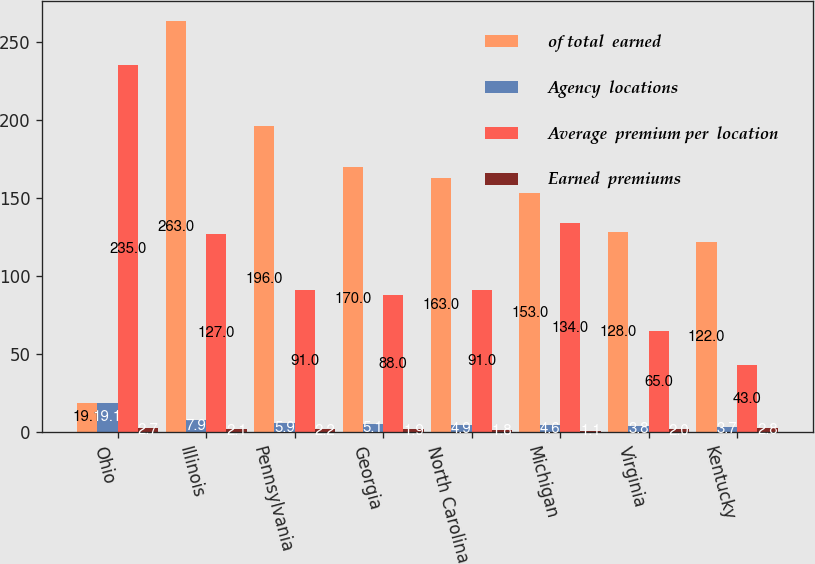Convert chart to OTSL. <chart><loc_0><loc_0><loc_500><loc_500><stacked_bar_chart><ecel><fcel>Ohio<fcel>Illinois<fcel>Pennsylvania<fcel>Georgia<fcel>North Carolina<fcel>Michigan<fcel>Virginia<fcel>Kentucky<nl><fcel>of total  earned<fcel>19.1<fcel>263<fcel>196<fcel>170<fcel>163<fcel>153<fcel>128<fcel>122<nl><fcel>Agency  locations<fcel>19.1<fcel>7.9<fcel>5.9<fcel>5.1<fcel>4.9<fcel>4.6<fcel>3.8<fcel>3.7<nl><fcel>Average  premium per  location<fcel>235<fcel>127<fcel>91<fcel>88<fcel>91<fcel>134<fcel>65<fcel>43<nl><fcel>Earned  premiums<fcel>2.7<fcel>2.1<fcel>2.2<fcel>1.9<fcel>1.8<fcel>1.1<fcel>2<fcel>2.8<nl></chart> 